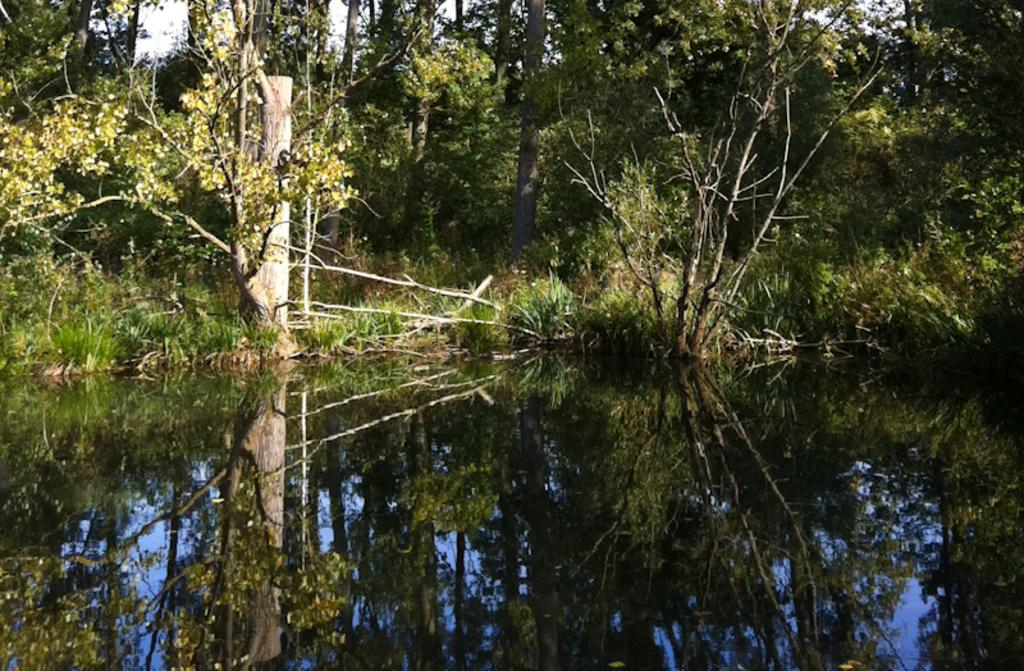What type of natural feature is present in the image? There is a lake in the image. What type of vegetation can be seen in the image? There are trees in the image. Where are the chairs placed in the image? There are no chairs present in the image. 